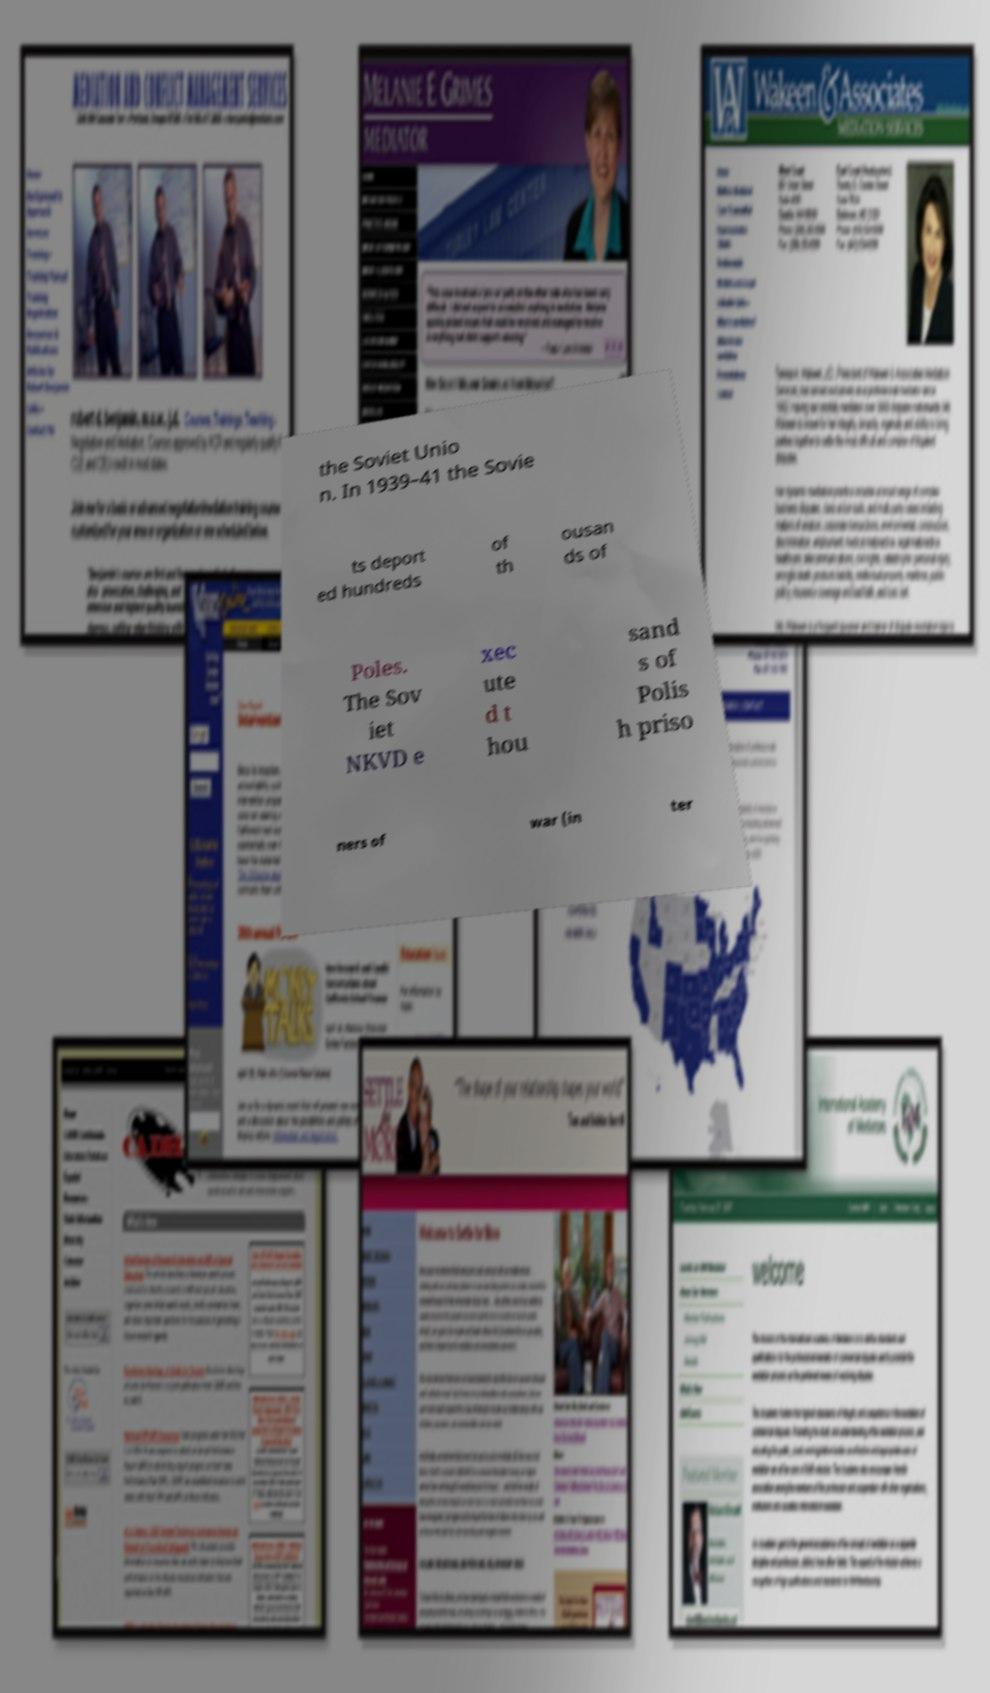Could you assist in decoding the text presented in this image and type it out clearly? the Soviet Unio n. In 1939–41 the Sovie ts deport ed hundreds of th ousan ds of Poles. The Sov iet NKVD e xec ute d t hou sand s of Polis h priso ners of war (in ter 